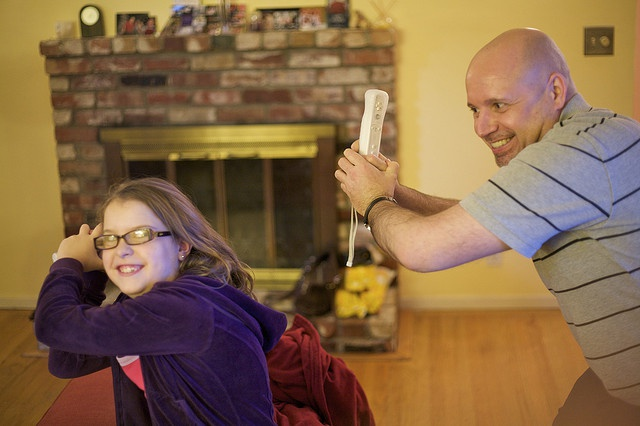Describe the objects in this image and their specific colors. I can see people in olive, gray, darkgray, and tan tones, people in olive, black, navy, tan, and brown tones, handbag in olive, black, maroon, and gray tones, handbag in olive, orange, and tan tones, and remote in olive, tan, and beige tones in this image. 